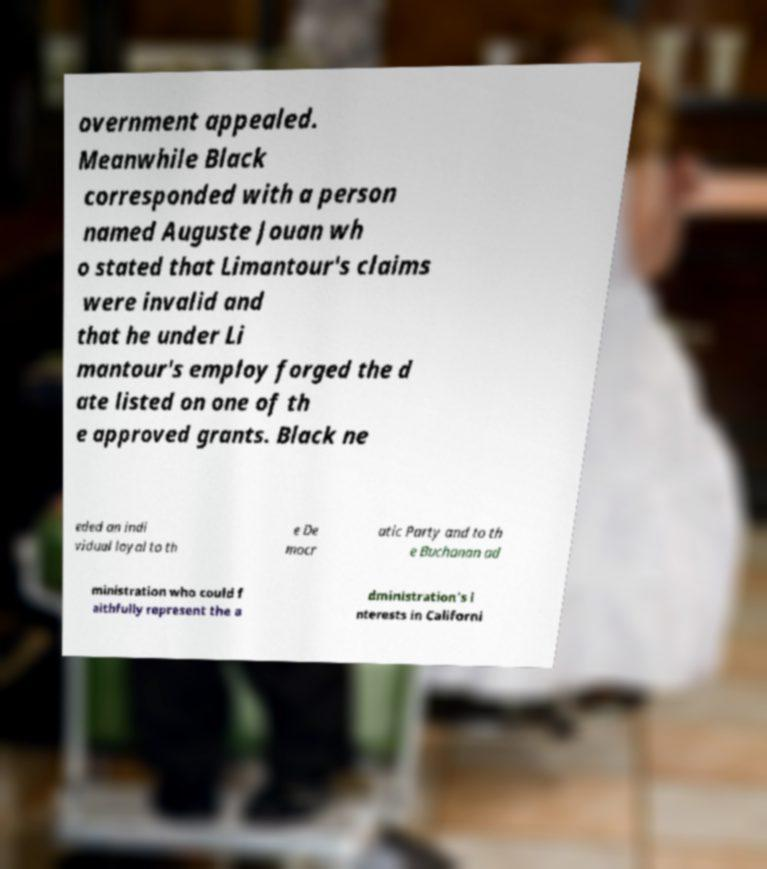There's text embedded in this image that I need extracted. Can you transcribe it verbatim? overnment appealed. Meanwhile Black corresponded with a person named Auguste Jouan wh o stated that Limantour's claims were invalid and that he under Li mantour's employ forged the d ate listed on one of th e approved grants. Black ne eded an indi vidual loyal to th e De mocr atic Party and to th e Buchanan ad ministration who could f aithfully represent the a dministration's i nterests in Californi 